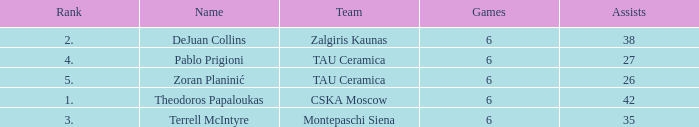What is the least number of assists among players ranked 2? 38.0. 